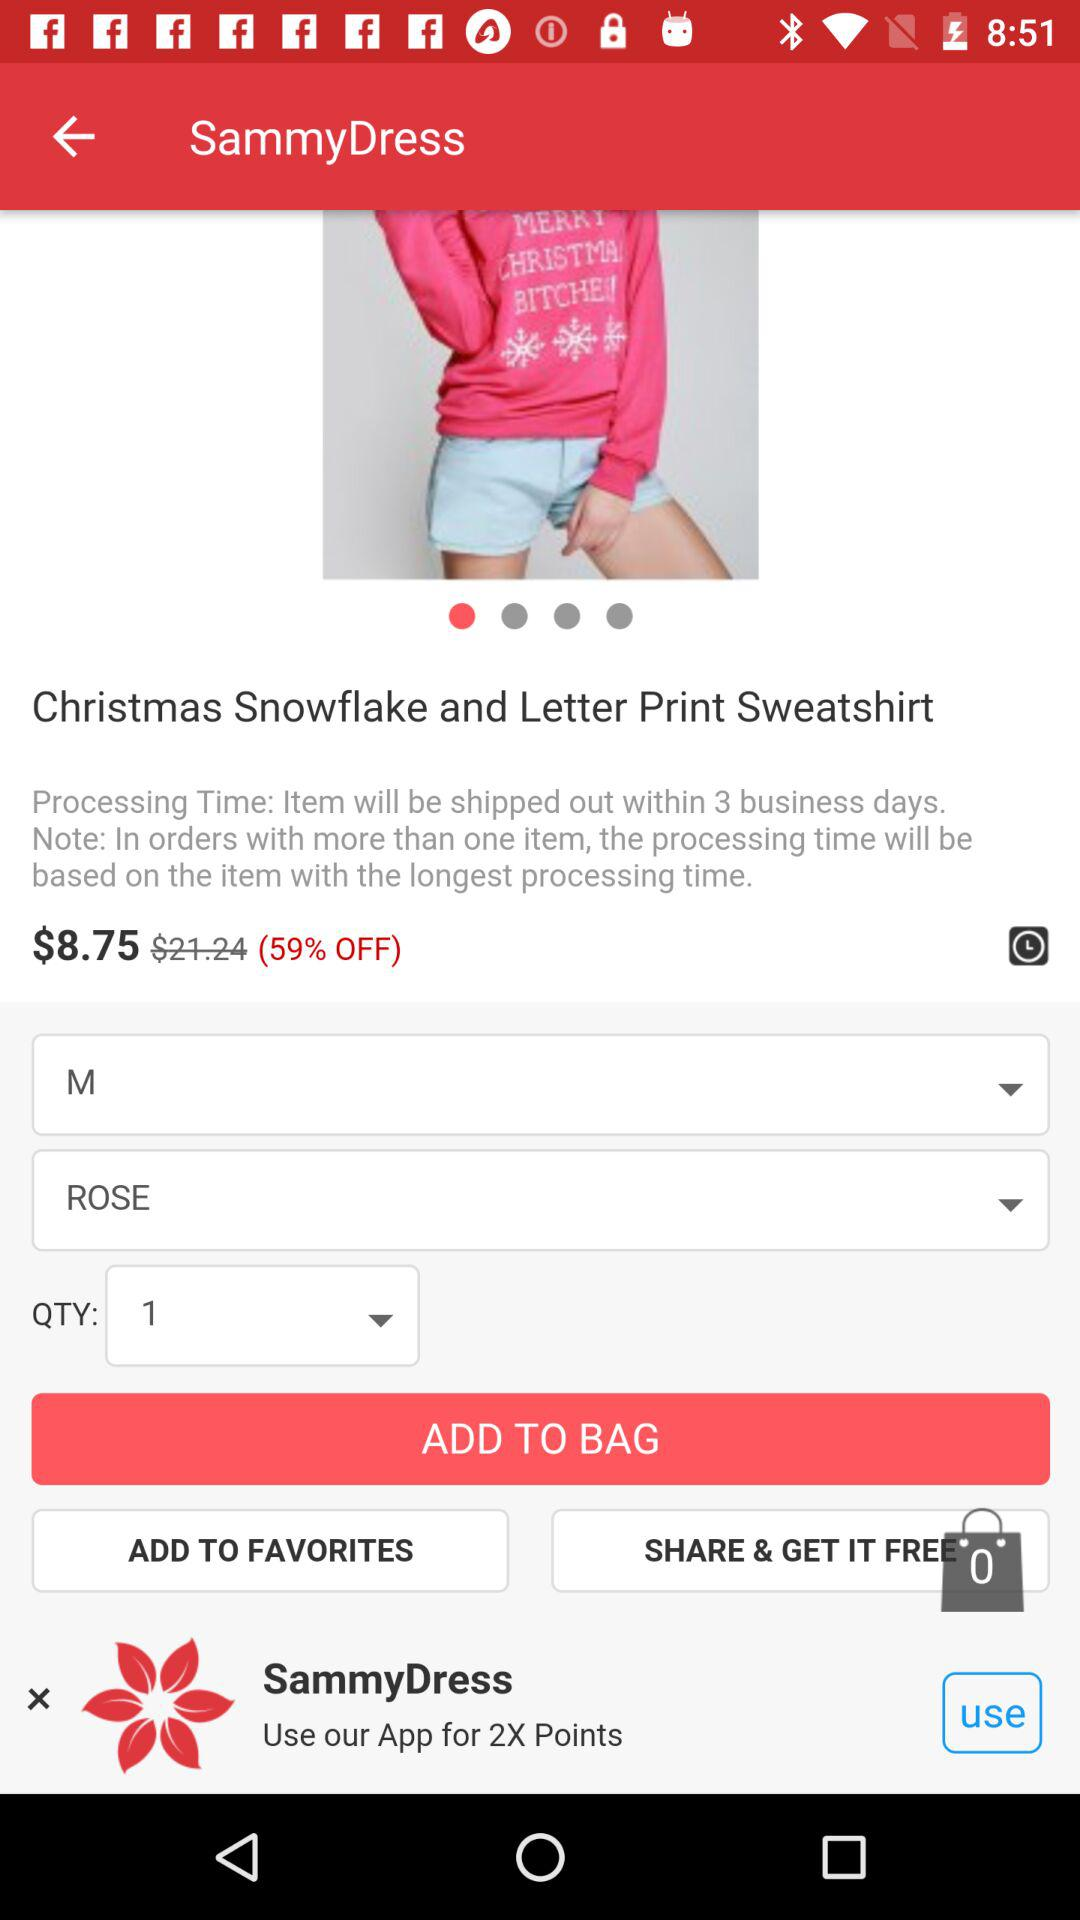What is the size of the sweatshirt? The size of the sweatshirt is medium. 